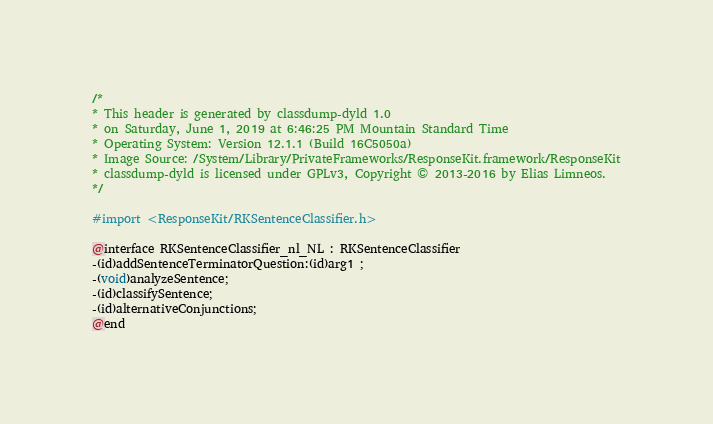<code> <loc_0><loc_0><loc_500><loc_500><_C_>/*
* This header is generated by classdump-dyld 1.0
* on Saturday, June 1, 2019 at 6:46:25 PM Mountain Standard Time
* Operating System: Version 12.1.1 (Build 16C5050a)
* Image Source: /System/Library/PrivateFrameworks/ResponseKit.framework/ResponseKit
* classdump-dyld is licensed under GPLv3, Copyright © 2013-2016 by Elias Limneos.
*/

#import <ResponseKit/RKSentenceClassifier.h>

@interface RKSentenceClassifier_nl_NL : RKSentenceClassifier
-(id)addSentenceTerminatorQuestion:(id)arg1 ;
-(void)analyzeSentence;
-(id)classifySentence;
-(id)alternativeConjunctions;
@end

</code> 